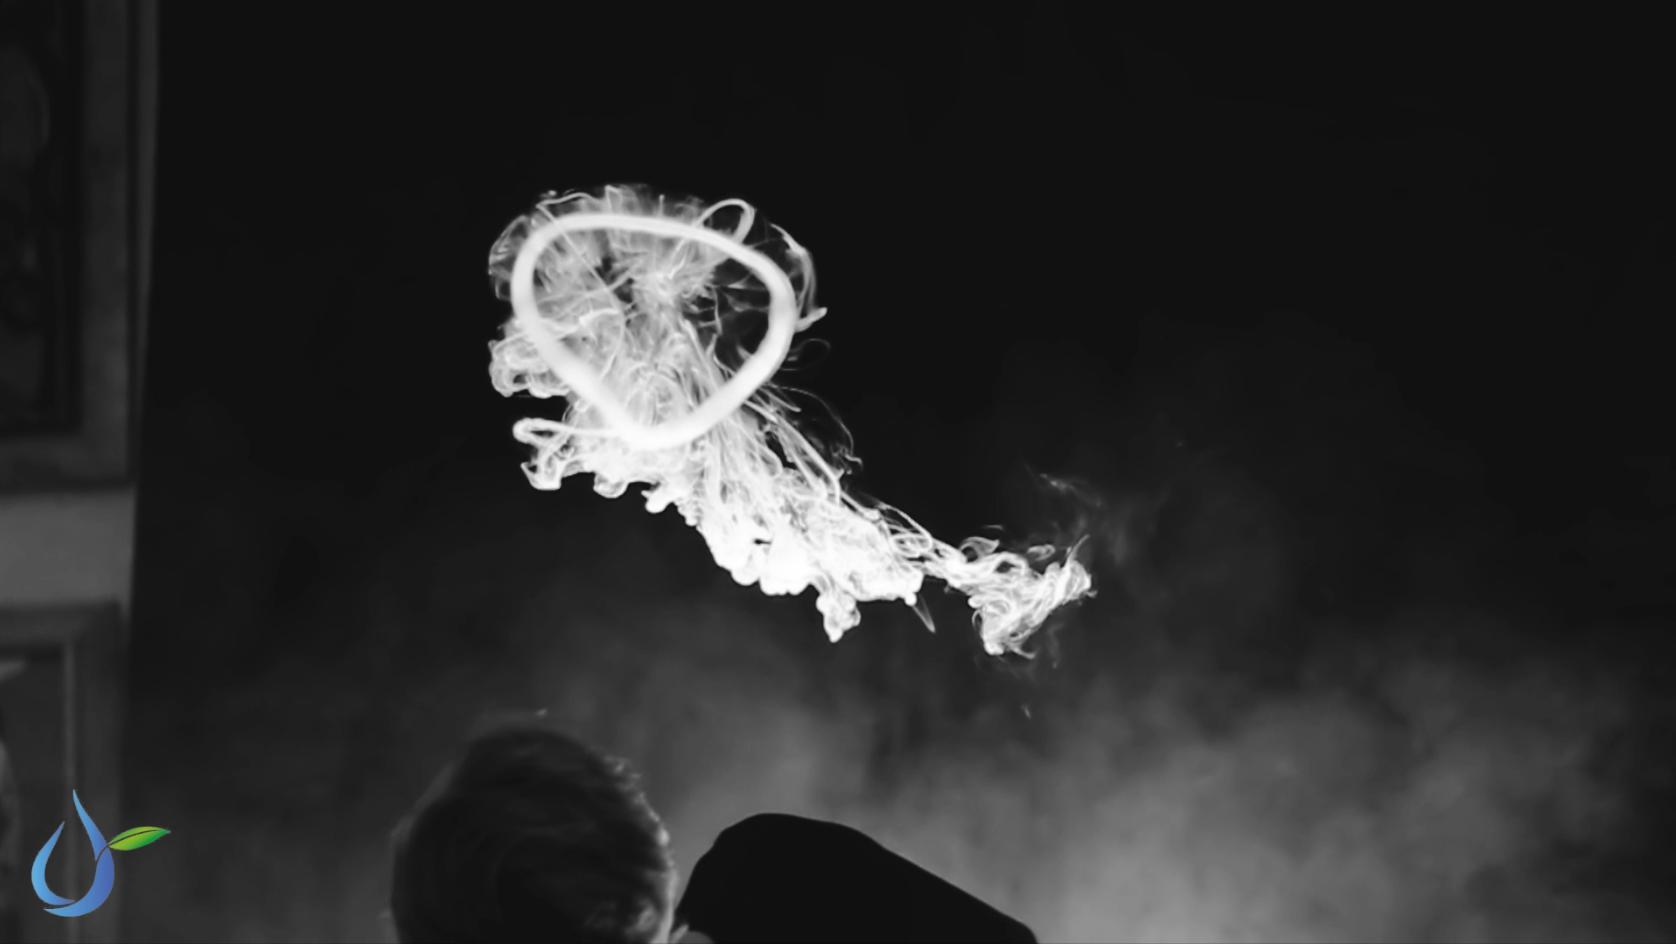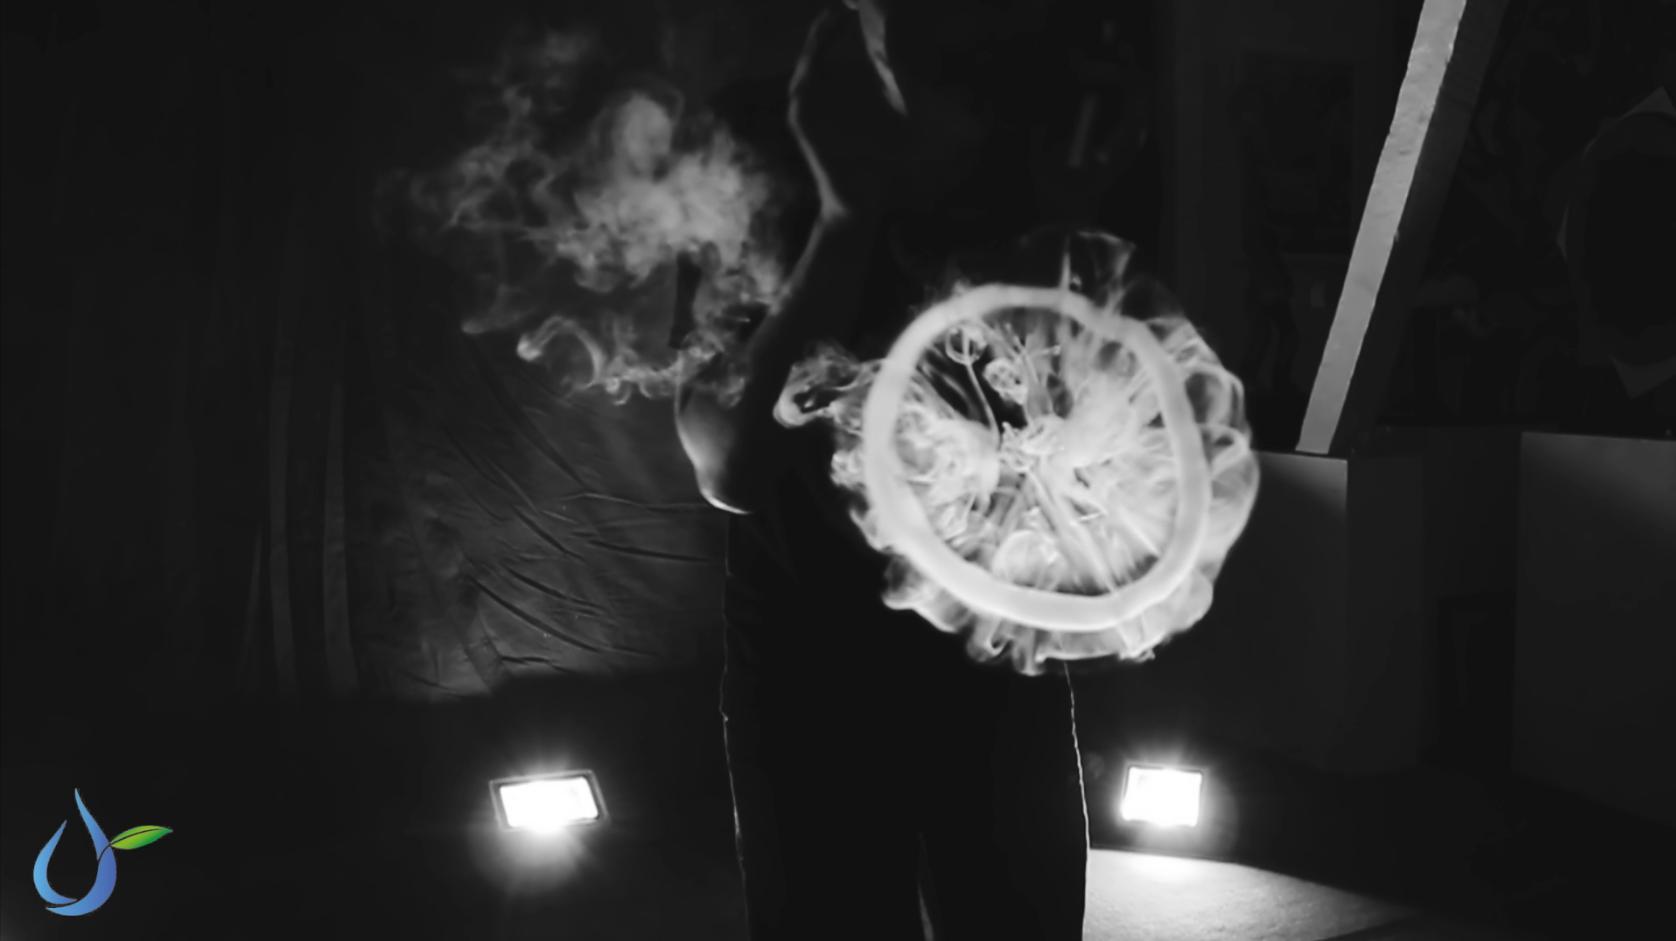The first image is the image on the left, the second image is the image on the right. Considering the images on both sides, is "The left and right image contains the same number of jelly fish looking smoke rings." valid? Answer yes or no. Yes. The first image is the image on the left, the second image is the image on the right. Examine the images to the left and right. Is the description "There are exactly two smoke rings." accurate? Answer yes or no. Yes. 